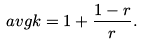Convert formula to latex. <formula><loc_0><loc_0><loc_500><loc_500>\ a v g { k } = 1 + \frac { 1 - r } { r } .</formula> 